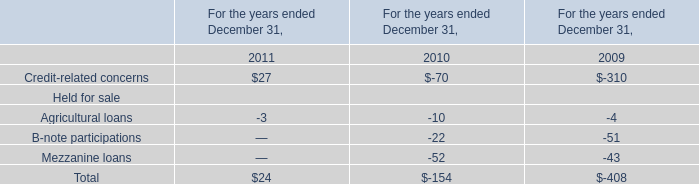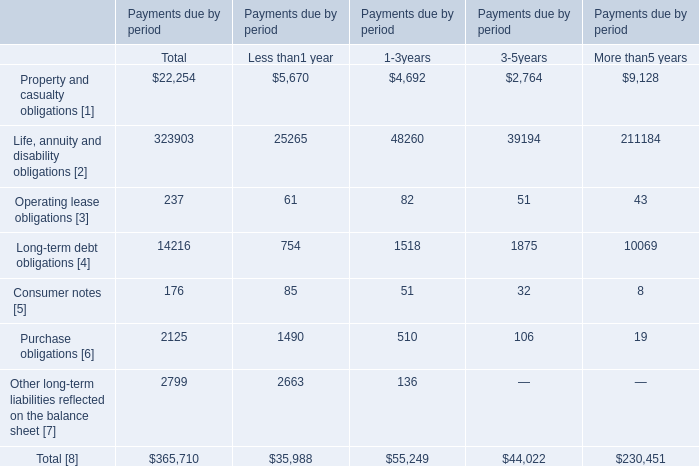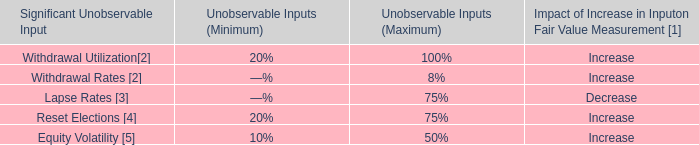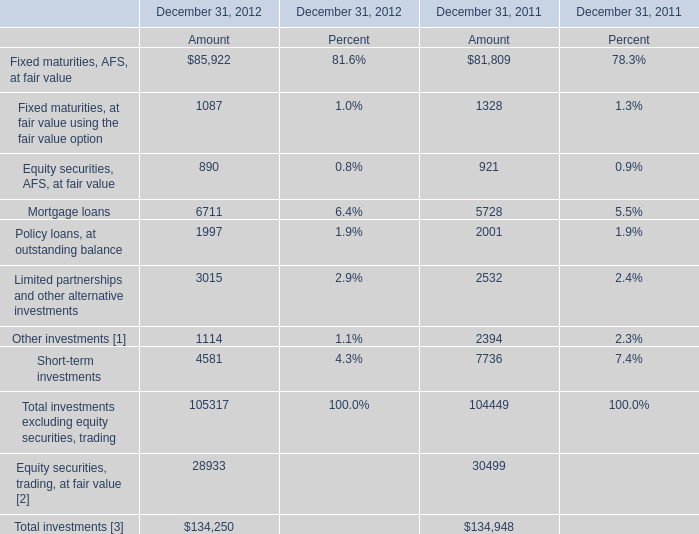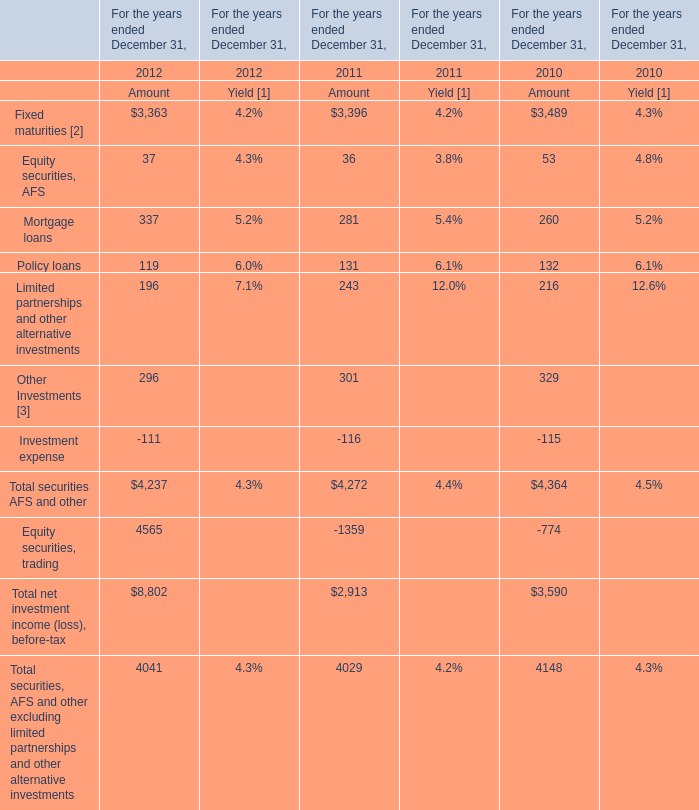What is the percentage of all Total securities AFS and other that are positive to the total amount, in 2012? 
Computations: ((((((3363 + 37) + 337) + 119) + 196) + 296) / 4237)
Answer: 1.0262. 